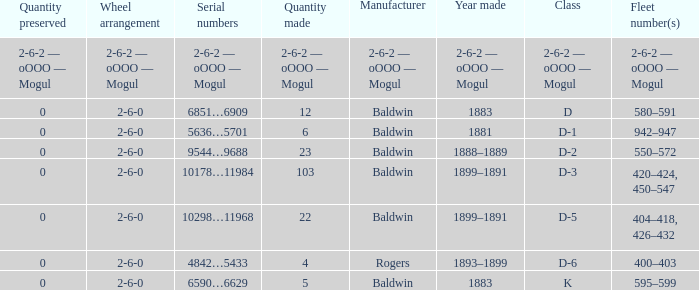What is the quantity made when the wheel arrangement is 2-6-0 and the class is k? 5.0. 